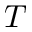<formula> <loc_0><loc_0><loc_500><loc_500>T</formula> 